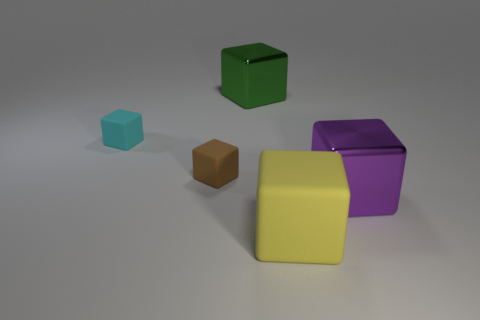There is a metal object that is to the right of the green thing; is it the same size as the matte thing behind the small brown rubber block?
Give a very brief answer. No. Is there a brown cube of the same size as the purple metallic object?
Keep it short and to the point. No. Does the yellow thing in front of the cyan rubber object have the same shape as the brown object?
Ensure brevity in your answer.  Yes. What is the object on the right side of the large yellow rubber object made of?
Provide a succinct answer. Metal. There is a purple thing that is right of the large block that is behind the tiny cyan rubber cube; what shape is it?
Your answer should be compact. Cube. Is the shape of the large yellow matte object the same as the metallic thing that is left of the purple thing?
Your answer should be very brief. Yes. There is a small cube that is in front of the small cyan thing; what number of rubber blocks are in front of it?
Offer a terse response. 1. There is another tiny thing that is the same shape as the cyan rubber thing; what material is it?
Provide a short and direct response. Rubber. How many cyan things are tiny matte blocks or metallic things?
Make the answer very short. 1. Is there any other thing of the same color as the big rubber thing?
Ensure brevity in your answer.  No. 